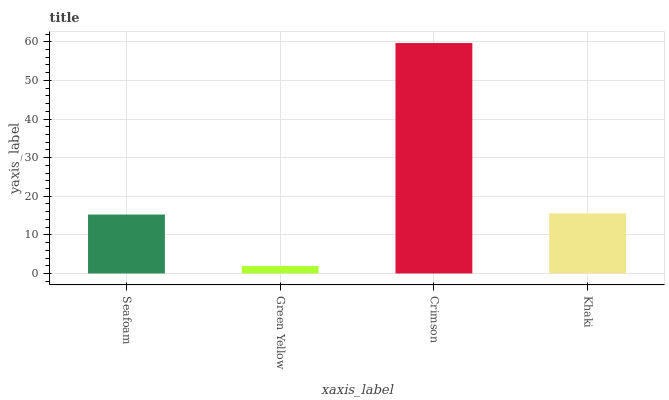Is Green Yellow the minimum?
Answer yes or no. Yes. Is Crimson the maximum?
Answer yes or no. Yes. Is Crimson the minimum?
Answer yes or no. No. Is Green Yellow the maximum?
Answer yes or no. No. Is Crimson greater than Green Yellow?
Answer yes or no. Yes. Is Green Yellow less than Crimson?
Answer yes or no. Yes. Is Green Yellow greater than Crimson?
Answer yes or no. No. Is Crimson less than Green Yellow?
Answer yes or no. No. Is Khaki the high median?
Answer yes or no. Yes. Is Seafoam the low median?
Answer yes or no. Yes. Is Green Yellow the high median?
Answer yes or no. No. Is Green Yellow the low median?
Answer yes or no. No. 